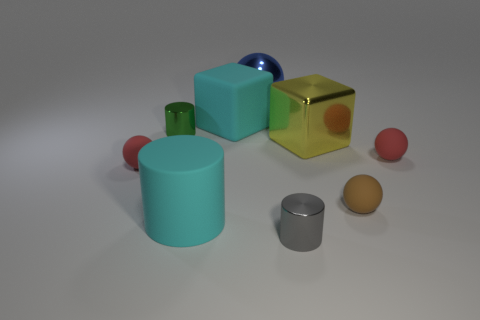Add 1 red things. How many objects exist? 10 Subtract all cylinders. How many objects are left? 6 Add 1 big purple matte blocks. How many big purple matte blocks exist? 1 Subtract 0 green cubes. How many objects are left? 9 Subtract all tiny things. Subtract all cyan cylinders. How many objects are left? 3 Add 6 large cylinders. How many large cylinders are left? 7 